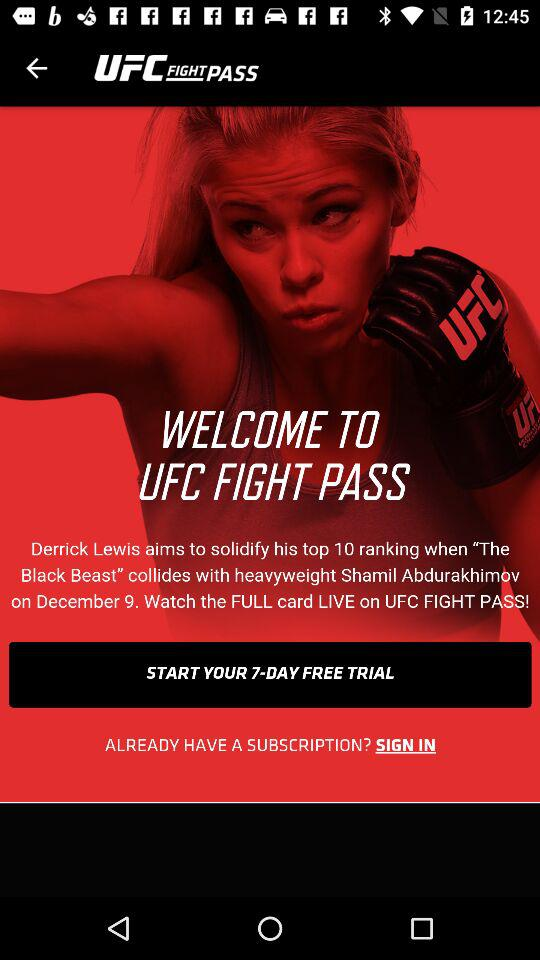What is the name of the application? The name of the application is "UFC FIGHT PASS". 